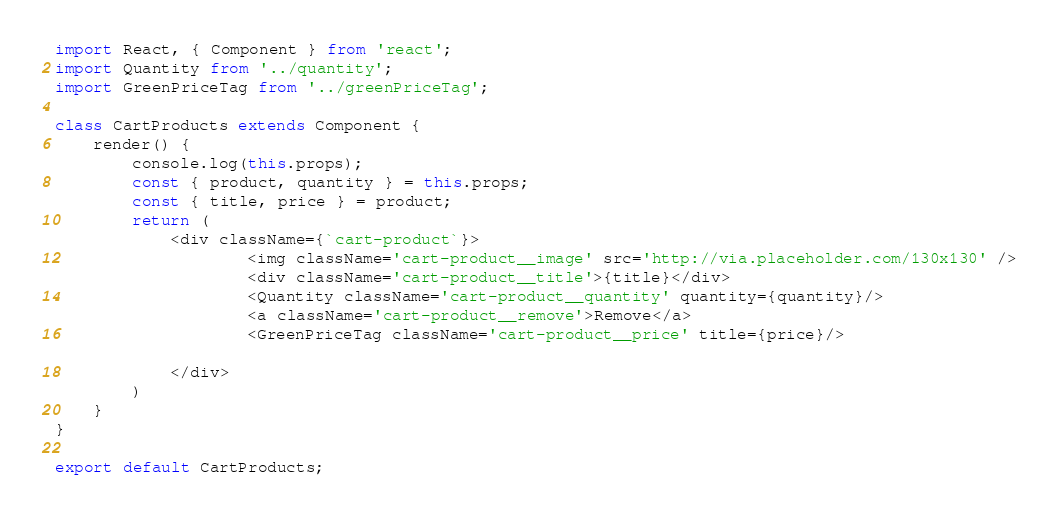<code> <loc_0><loc_0><loc_500><loc_500><_JavaScript_>import React, { Component } from 'react';
import Quantity from '../quantity';
import GreenPriceTag from '../greenPriceTag';

class CartProducts extends Component {
    render() {
        console.log(this.props);
        const { product, quantity } = this.props;
        const { title, price } = product;
        return (
            <div className={`cart-product`}>
                    <img className='cart-product__image' src='http://via.placeholder.com/130x130' />
                    <div className='cart-product__title'>{title}</div>
                    <Quantity className='cart-product__quantity' quantity={quantity}/>
                    <a className='cart-product__remove'>Remove</a>
                    <GreenPriceTag className='cart-product__price' title={price}/>
                
            </div>
        )
    }
}

export default CartProducts;
</code> 